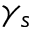<formula> <loc_0><loc_0><loc_500><loc_500>\gamma _ { s }</formula> 